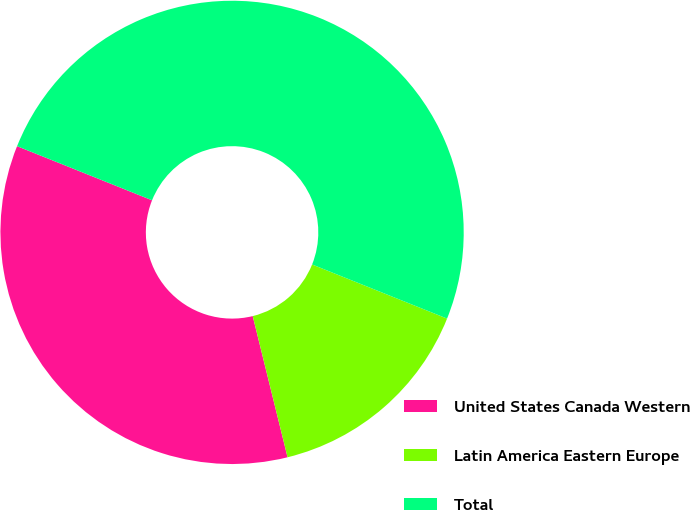<chart> <loc_0><loc_0><loc_500><loc_500><pie_chart><fcel>United States Canada Western<fcel>Latin America Eastern Europe<fcel>Total<nl><fcel>34.92%<fcel>15.08%<fcel>50.0%<nl></chart> 